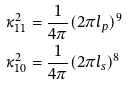Convert formula to latex. <formula><loc_0><loc_0><loc_500><loc_500>\kappa _ { 1 1 } ^ { 2 } & = \frac { 1 } { 4 \pi } ( 2 \pi l _ { p } ) ^ { 9 } \\ \kappa _ { 1 0 } ^ { 2 } & = \frac { 1 } { 4 \pi } ( 2 \pi l _ { s } ) ^ { 8 }</formula> 